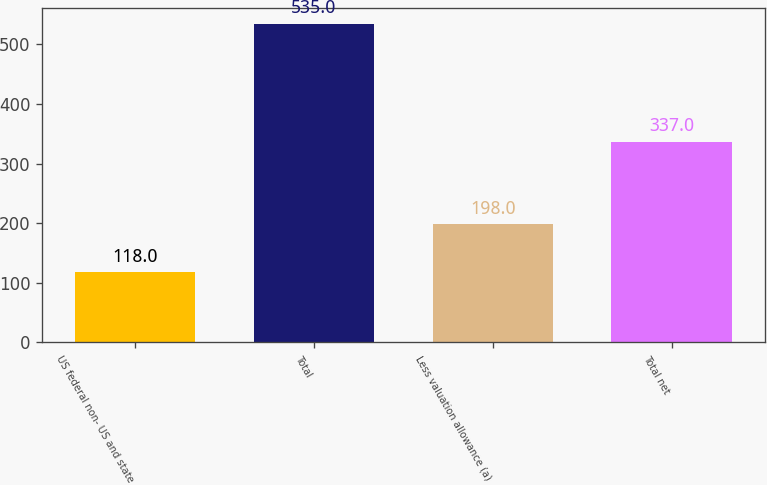Convert chart to OTSL. <chart><loc_0><loc_0><loc_500><loc_500><bar_chart><fcel>US federal non- US and state<fcel>Total<fcel>Less valuation allowance (a)<fcel>Total net<nl><fcel>118<fcel>535<fcel>198<fcel>337<nl></chart> 